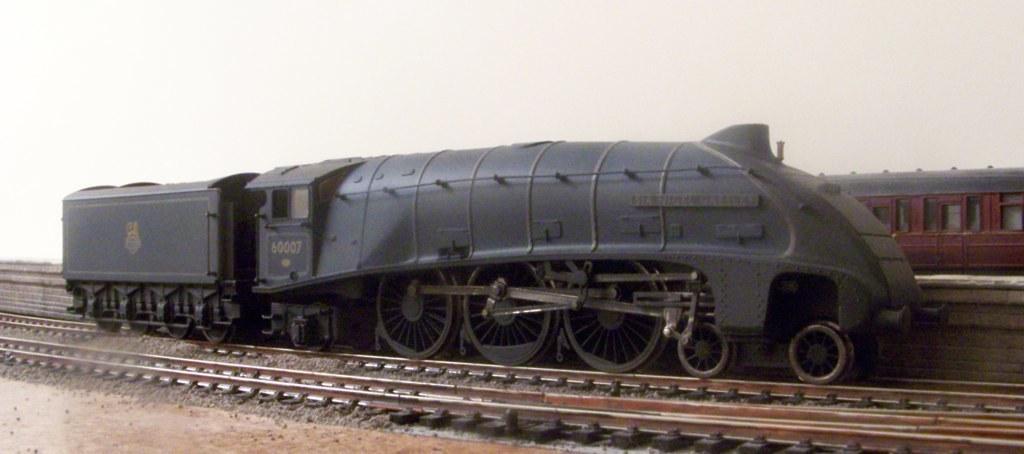Please provide a concise description of this image. In this picture we can see trains on railway tracks, stones and in the background we can see the sky. 